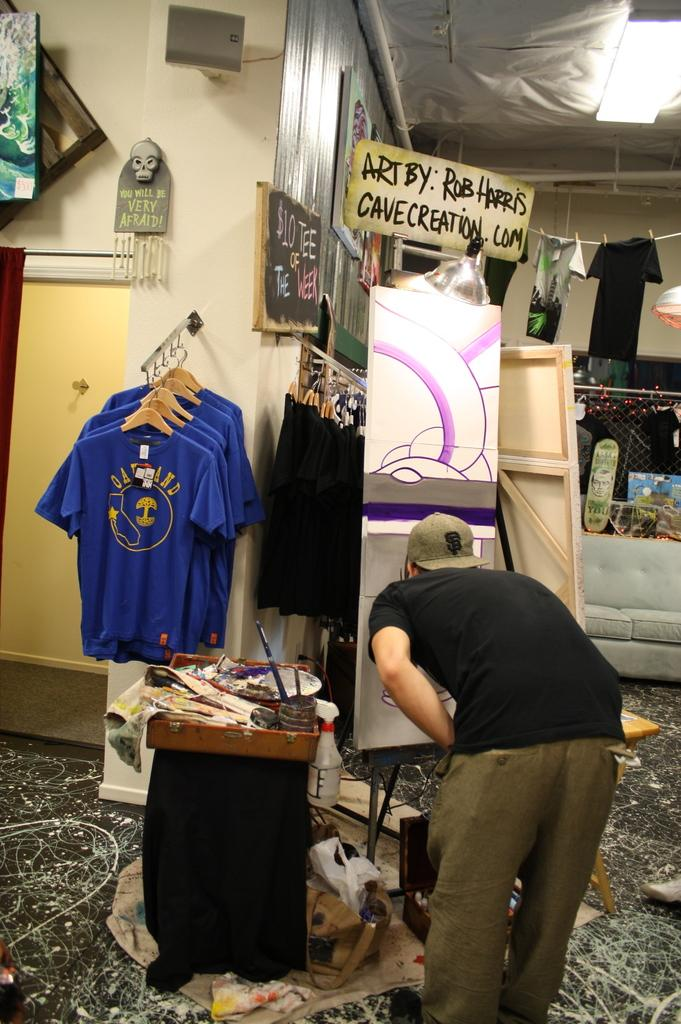Provide a one-sentence caption for the provided image. an art display by Rob Harris with a website name of cavecreation.com. 